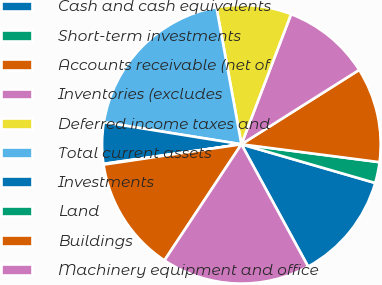Convert chart. <chart><loc_0><loc_0><loc_500><loc_500><pie_chart><fcel>Cash and cash equivalents<fcel>Short-term investments<fcel>Accounts receivable (net of<fcel>Inventories (excludes<fcel>Deferred income taxes and<fcel>Total current assets<fcel>Investments<fcel>Land<fcel>Buildings<fcel>Machinery equipment and office<nl><fcel>12.57%<fcel>2.43%<fcel>11.01%<fcel>10.23%<fcel>8.67%<fcel>19.6%<fcel>4.77%<fcel>0.09%<fcel>13.35%<fcel>17.26%<nl></chart> 